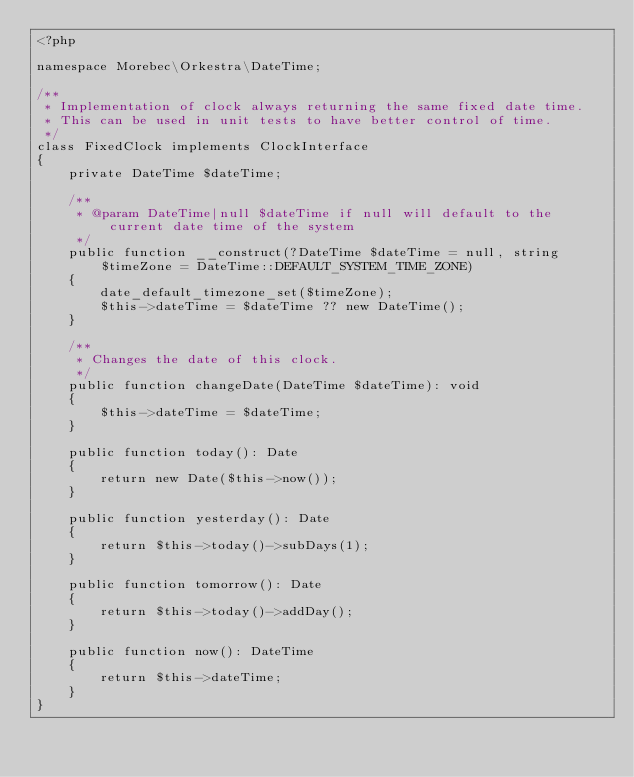Convert code to text. <code><loc_0><loc_0><loc_500><loc_500><_PHP_><?php

namespace Morebec\Orkestra\DateTime;

/**
 * Implementation of clock always returning the same fixed date time.
 * This can be used in unit tests to have better control of time.
 */
class FixedClock implements ClockInterface
{
    private DateTime $dateTime;

    /**
     * @param DateTime|null $dateTime if null will default to the current date time of the system
     */
    public function __construct(?DateTime $dateTime = null, string $timeZone = DateTime::DEFAULT_SYSTEM_TIME_ZONE)
    {
        date_default_timezone_set($timeZone);
        $this->dateTime = $dateTime ?? new DateTime();
    }

    /**
     * Changes the date of this clock.
     */
    public function changeDate(DateTime $dateTime): void
    {
        $this->dateTime = $dateTime;
    }

    public function today(): Date
    {
        return new Date($this->now());
    }

    public function yesterday(): Date
    {
        return $this->today()->subDays(1);
    }

    public function tomorrow(): Date
    {
        return $this->today()->addDay();
    }

    public function now(): DateTime
    {
        return $this->dateTime;
    }
}
</code> 